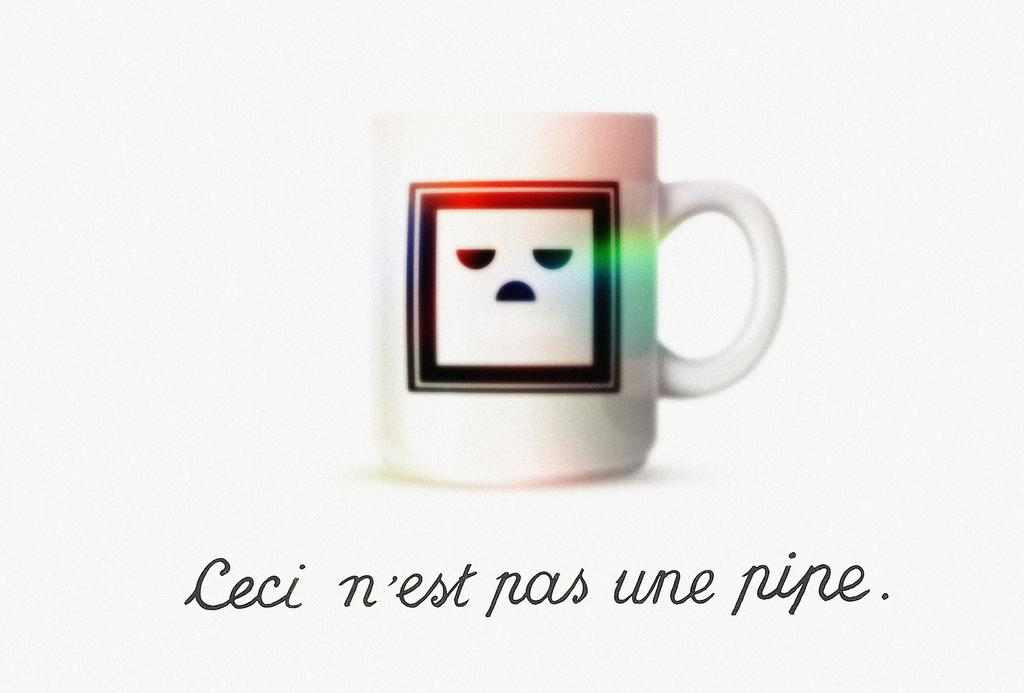<image>
Give a short and clear explanation of the subsequent image. A glas coffee mug with an angry face with the text leci n'est pas un pipe on the bottom. 